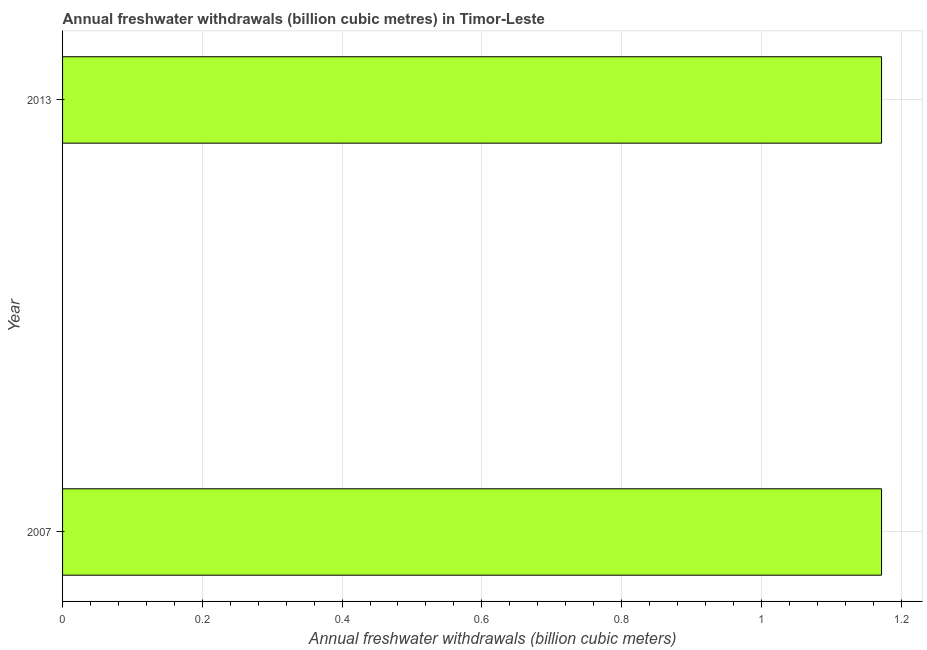What is the title of the graph?
Your answer should be very brief. Annual freshwater withdrawals (billion cubic metres) in Timor-Leste. What is the label or title of the X-axis?
Offer a very short reply. Annual freshwater withdrawals (billion cubic meters). What is the label or title of the Y-axis?
Your answer should be very brief. Year. What is the annual freshwater withdrawals in 2007?
Ensure brevity in your answer.  1.17. Across all years, what is the maximum annual freshwater withdrawals?
Offer a terse response. 1.17. Across all years, what is the minimum annual freshwater withdrawals?
Provide a short and direct response. 1.17. What is the sum of the annual freshwater withdrawals?
Your response must be concise. 2.34. What is the difference between the annual freshwater withdrawals in 2007 and 2013?
Give a very brief answer. 0. What is the average annual freshwater withdrawals per year?
Your answer should be compact. 1.17. What is the median annual freshwater withdrawals?
Your response must be concise. 1.17. What is the ratio of the annual freshwater withdrawals in 2007 to that in 2013?
Keep it short and to the point. 1. How many bars are there?
Your response must be concise. 2. How many years are there in the graph?
Keep it short and to the point. 2. What is the difference between two consecutive major ticks on the X-axis?
Your response must be concise. 0.2. What is the Annual freshwater withdrawals (billion cubic meters) of 2007?
Your answer should be compact. 1.17. What is the Annual freshwater withdrawals (billion cubic meters) in 2013?
Your answer should be compact. 1.17. 